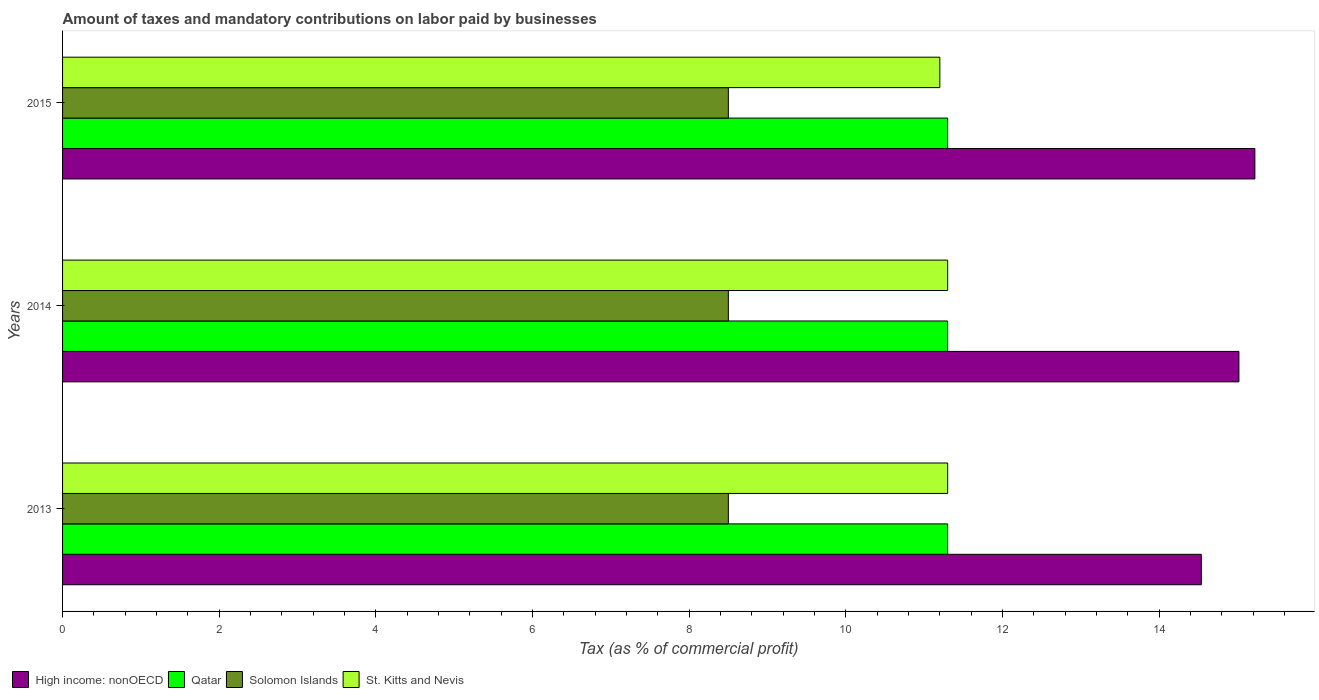What is the label of the 1st group of bars from the top?
Your answer should be very brief. 2015. What is the percentage of taxes paid by businesses in Solomon Islands in 2013?
Your response must be concise. 8.5. Across all years, what is the minimum percentage of taxes paid by businesses in Solomon Islands?
Your response must be concise. 8.5. In which year was the percentage of taxes paid by businesses in High income: nonOECD maximum?
Give a very brief answer. 2015. What is the total percentage of taxes paid by businesses in St. Kitts and Nevis in the graph?
Provide a succinct answer. 33.8. What is the difference between the percentage of taxes paid by businesses in St. Kitts and Nevis in 2014 and that in 2015?
Offer a terse response. 0.1. What is the difference between the percentage of taxes paid by businesses in Solomon Islands in 2013 and the percentage of taxes paid by businesses in High income: nonOECD in 2015?
Provide a succinct answer. -6.72. What is the average percentage of taxes paid by businesses in St. Kitts and Nevis per year?
Ensure brevity in your answer.  11.27. In the year 2015, what is the difference between the percentage of taxes paid by businesses in Qatar and percentage of taxes paid by businesses in St. Kitts and Nevis?
Your response must be concise. 0.1. In how many years, is the percentage of taxes paid by businesses in St. Kitts and Nevis greater than 4.8 %?
Your answer should be very brief. 3. What is the ratio of the percentage of taxes paid by businesses in High income: nonOECD in 2013 to that in 2014?
Keep it short and to the point. 0.97. Is the percentage of taxes paid by businesses in Qatar in 2014 less than that in 2015?
Your answer should be compact. No. Is the difference between the percentage of taxes paid by businesses in Qatar in 2014 and 2015 greater than the difference between the percentage of taxes paid by businesses in St. Kitts and Nevis in 2014 and 2015?
Offer a very short reply. No. What is the difference between the highest and the second highest percentage of taxes paid by businesses in Solomon Islands?
Offer a very short reply. 0. What is the difference between the highest and the lowest percentage of taxes paid by businesses in Qatar?
Provide a short and direct response. 0. What does the 2nd bar from the top in 2013 represents?
Provide a short and direct response. Solomon Islands. What does the 2nd bar from the bottom in 2015 represents?
Your answer should be compact. Qatar. Are all the bars in the graph horizontal?
Your answer should be compact. Yes. How many years are there in the graph?
Keep it short and to the point. 3. Are the values on the major ticks of X-axis written in scientific E-notation?
Your answer should be very brief. No. Does the graph contain grids?
Ensure brevity in your answer.  No. Where does the legend appear in the graph?
Provide a succinct answer. Bottom left. How many legend labels are there?
Your answer should be very brief. 4. What is the title of the graph?
Provide a succinct answer. Amount of taxes and mandatory contributions on labor paid by businesses. What is the label or title of the X-axis?
Give a very brief answer. Tax (as % of commercial profit). What is the Tax (as % of commercial profit) in High income: nonOECD in 2013?
Keep it short and to the point. 14.54. What is the Tax (as % of commercial profit) of High income: nonOECD in 2014?
Your answer should be very brief. 15.02. What is the Tax (as % of commercial profit) of Qatar in 2014?
Keep it short and to the point. 11.3. What is the Tax (as % of commercial profit) in St. Kitts and Nevis in 2014?
Ensure brevity in your answer.  11.3. What is the Tax (as % of commercial profit) of High income: nonOECD in 2015?
Provide a succinct answer. 15.22. What is the Tax (as % of commercial profit) of Qatar in 2015?
Your answer should be very brief. 11.3. What is the Tax (as % of commercial profit) of Solomon Islands in 2015?
Your response must be concise. 8.5. Across all years, what is the maximum Tax (as % of commercial profit) in High income: nonOECD?
Keep it short and to the point. 15.22. Across all years, what is the maximum Tax (as % of commercial profit) of Qatar?
Offer a very short reply. 11.3. Across all years, what is the maximum Tax (as % of commercial profit) of St. Kitts and Nevis?
Give a very brief answer. 11.3. Across all years, what is the minimum Tax (as % of commercial profit) in High income: nonOECD?
Your answer should be very brief. 14.54. What is the total Tax (as % of commercial profit) of High income: nonOECD in the graph?
Make the answer very short. 44.78. What is the total Tax (as % of commercial profit) of Qatar in the graph?
Ensure brevity in your answer.  33.9. What is the total Tax (as % of commercial profit) in St. Kitts and Nevis in the graph?
Provide a succinct answer. 33.8. What is the difference between the Tax (as % of commercial profit) of High income: nonOECD in 2013 and that in 2014?
Offer a terse response. -0.48. What is the difference between the Tax (as % of commercial profit) in High income: nonOECD in 2013 and that in 2015?
Give a very brief answer. -0.68. What is the difference between the Tax (as % of commercial profit) in Qatar in 2013 and that in 2015?
Provide a short and direct response. 0. What is the difference between the Tax (as % of commercial profit) of Solomon Islands in 2013 and that in 2015?
Ensure brevity in your answer.  0. What is the difference between the Tax (as % of commercial profit) in High income: nonOECD in 2014 and that in 2015?
Give a very brief answer. -0.2. What is the difference between the Tax (as % of commercial profit) of Qatar in 2014 and that in 2015?
Keep it short and to the point. 0. What is the difference between the Tax (as % of commercial profit) in Solomon Islands in 2014 and that in 2015?
Offer a very short reply. 0. What is the difference between the Tax (as % of commercial profit) in St. Kitts and Nevis in 2014 and that in 2015?
Your response must be concise. 0.1. What is the difference between the Tax (as % of commercial profit) of High income: nonOECD in 2013 and the Tax (as % of commercial profit) of Qatar in 2014?
Make the answer very short. 3.24. What is the difference between the Tax (as % of commercial profit) of High income: nonOECD in 2013 and the Tax (as % of commercial profit) of Solomon Islands in 2014?
Your answer should be very brief. 6.04. What is the difference between the Tax (as % of commercial profit) in High income: nonOECD in 2013 and the Tax (as % of commercial profit) in St. Kitts and Nevis in 2014?
Your answer should be very brief. 3.24. What is the difference between the Tax (as % of commercial profit) of Qatar in 2013 and the Tax (as % of commercial profit) of St. Kitts and Nevis in 2014?
Provide a short and direct response. 0. What is the difference between the Tax (as % of commercial profit) of High income: nonOECD in 2013 and the Tax (as % of commercial profit) of Qatar in 2015?
Provide a succinct answer. 3.24. What is the difference between the Tax (as % of commercial profit) in High income: nonOECD in 2013 and the Tax (as % of commercial profit) in Solomon Islands in 2015?
Offer a very short reply. 6.04. What is the difference between the Tax (as % of commercial profit) in High income: nonOECD in 2013 and the Tax (as % of commercial profit) in St. Kitts and Nevis in 2015?
Your response must be concise. 3.34. What is the difference between the Tax (as % of commercial profit) in Solomon Islands in 2013 and the Tax (as % of commercial profit) in St. Kitts and Nevis in 2015?
Make the answer very short. -2.7. What is the difference between the Tax (as % of commercial profit) in High income: nonOECD in 2014 and the Tax (as % of commercial profit) in Qatar in 2015?
Ensure brevity in your answer.  3.72. What is the difference between the Tax (as % of commercial profit) in High income: nonOECD in 2014 and the Tax (as % of commercial profit) in Solomon Islands in 2015?
Your response must be concise. 6.52. What is the difference between the Tax (as % of commercial profit) in High income: nonOECD in 2014 and the Tax (as % of commercial profit) in St. Kitts and Nevis in 2015?
Ensure brevity in your answer.  3.82. What is the difference between the Tax (as % of commercial profit) in Qatar in 2014 and the Tax (as % of commercial profit) in Solomon Islands in 2015?
Provide a short and direct response. 2.8. What is the average Tax (as % of commercial profit) in High income: nonOECD per year?
Give a very brief answer. 14.93. What is the average Tax (as % of commercial profit) of Qatar per year?
Your response must be concise. 11.3. What is the average Tax (as % of commercial profit) of St. Kitts and Nevis per year?
Give a very brief answer. 11.27. In the year 2013, what is the difference between the Tax (as % of commercial profit) in High income: nonOECD and Tax (as % of commercial profit) in Qatar?
Make the answer very short. 3.24. In the year 2013, what is the difference between the Tax (as % of commercial profit) of High income: nonOECD and Tax (as % of commercial profit) of Solomon Islands?
Offer a very short reply. 6.04. In the year 2013, what is the difference between the Tax (as % of commercial profit) in High income: nonOECD and Tax (as % of commercial profit) in St. Kitts and Nevis?
Your answer should be compact. 3.24. In the year 2014, what is the difference between the Tax (as % of commercial profit) in High income: nonOECD and Tax (as % of commercial profit) in Qatar?
Provide a succinct answer. 3.72. In the year 2014, what is the difference between the Tax (as % of commercial profit) in High income: nonOECD and Tax (as % of commercial profit) in Solomon Islands?
Keep it short and to the point. 6.52. In the year 2014, what is the difference between the Tax (as % of commercial profit) of High income: nonOECD and Tax (as % of commercial profit) of St. Kitts and Nevis?
Your answer should be very brief. 3.72. In the year 2014, what is the difference between the Tax (as % of commercial profit) of Qatar and Tax (as % of commercial profit) of Solomon Islands?
Provide a succinct answer. 2.8. In the year 2015, what is the difference between the Tax (as % of commercial profit) of High income: nonOECD and Tax (as % of commercial profit) of Qatar?
Provide a succinct answer. 3.92. In the year 2015, what is the difference between the Tax (as % of commercial profit) in High income: nonOECD and Tax (as % of commercial profit) in Solomon Islands?
Your answer should be compact. 6.72. In the year 2015, what is the difference between the Tax (as % of commercial profit) in High income: nonOECD and Tax (as % of commercial profit) in St. Kitts and Nevis?
Keep it short and to the point. 4.02. In the year 2015, what is the difference between the Tax (as % of commercial profit) in Qatar and Tax (as % of commercial profit) in Solomon Islands?
Your answer should be compact. 2.8. What is the ratio of the Tax (as % of commercial profit) of High income: nonOECD in 2013 to that in 2014?
Give a very brief answer. 0.97. What is the ratio of the Tax (as % of commercial profit) of Qatar in 2013 to that in 2014?
Offer a terse response. 1. What is the ratio of the Tax (as % of commercial profit) in St. Kitts and Nevis in 2013 to that in 2014?
Keep it short and to the point. 1. What is the ratio of the Tax (as % of commercial profit) in High income: nonOECD in 2013 to that in 2015?
Keep it short and to the point. 0.96. What is the ratio of the Tax (as % of commercial profit) of Qatar in 2013 to that in 2015?
Provide a short and direct response. 1. What is the ratio of the Tax (as % of commercial profit) in Solomon Islands in 2013 to that in 2015?
Provide a short and direct response. 1. What is the ratio of the Tax (as % of commercial profit) of St. Kitts and Nevis in 2013 to that in 2015?
Your answer should be very brief. 1.01. What is the ratio of the Tax (as % of commercial profit) of High income: nonOECD in 2014 to that in 2015?
Offer a very short reply. 0.99. What is the ratio of the Tax (as % of commercial profit) in Solomon Islands in 2014 to that in 2015?
Ensure brevity in your answer.  1. What is the ratio of the Tax (as % of commercial profit) of St. Kitts and Nevis in 2014 to that in 2015?
Ensure brevity in your answer.  1.01. What is the difference between the highest and the second highest Tax (as % of commercial profit) of High income: nonOECD?
Provide a succinct answer. 0.2. What is the difference between the highest and the second highest Tax (as % of commercial profit) of Solomon Islands?
Your response must be concise. 0. What is the difference between the highest and the lowest Tax (as % of commercial profit) of High income: nonOECD?
Make the answer very short. 0.68. What is the difference between the highest and the lowest Tax (as % of commercial profit) of Qatar?
Provide a succinct answer. 0. 